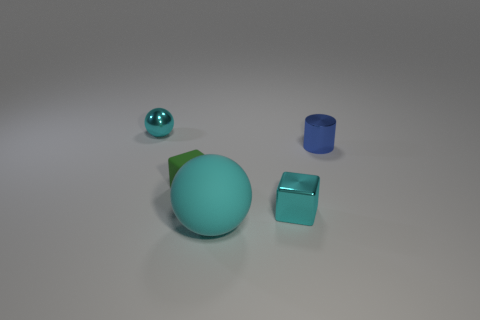There is a small metal object to the left of the big rubber ball; does it have the same color as the object in front of the tiny cyan block?
Offer a terse response. Yes. What size is the metal cube that is the same color as the small metallic ball?
Your answer should be very brief. Small. Do the large object and the small metal sphere have the same color?
Keep it short and to the point. Yes. Do the big cyan sphere and the small cyan thing behind the green block have the same material?
Your answer should be compact. No. What is the shape of the cyan metal object that is in front of the sphere behind the cyan matte sphere?
Ensure brevity in your answer.  Cube. Does the metal object to the left of the green matte thing have the same size as the big thing?
Ensure brevity in your answer.  No. What number of other things are the same shape as the small green rubber thing?
Give a very brief answer. 1. Does the ball that is in front of the small cyan metallic block have the same color as the shiny ball?
Your answer should be compact. Yes. Is there a tiny thing of the same color as the small metallic sphere?
Your response must be concise. Yes. There is a tiny cylinder; how many metallic cylinders are in front of it?
Give a very brief answer. 0. 